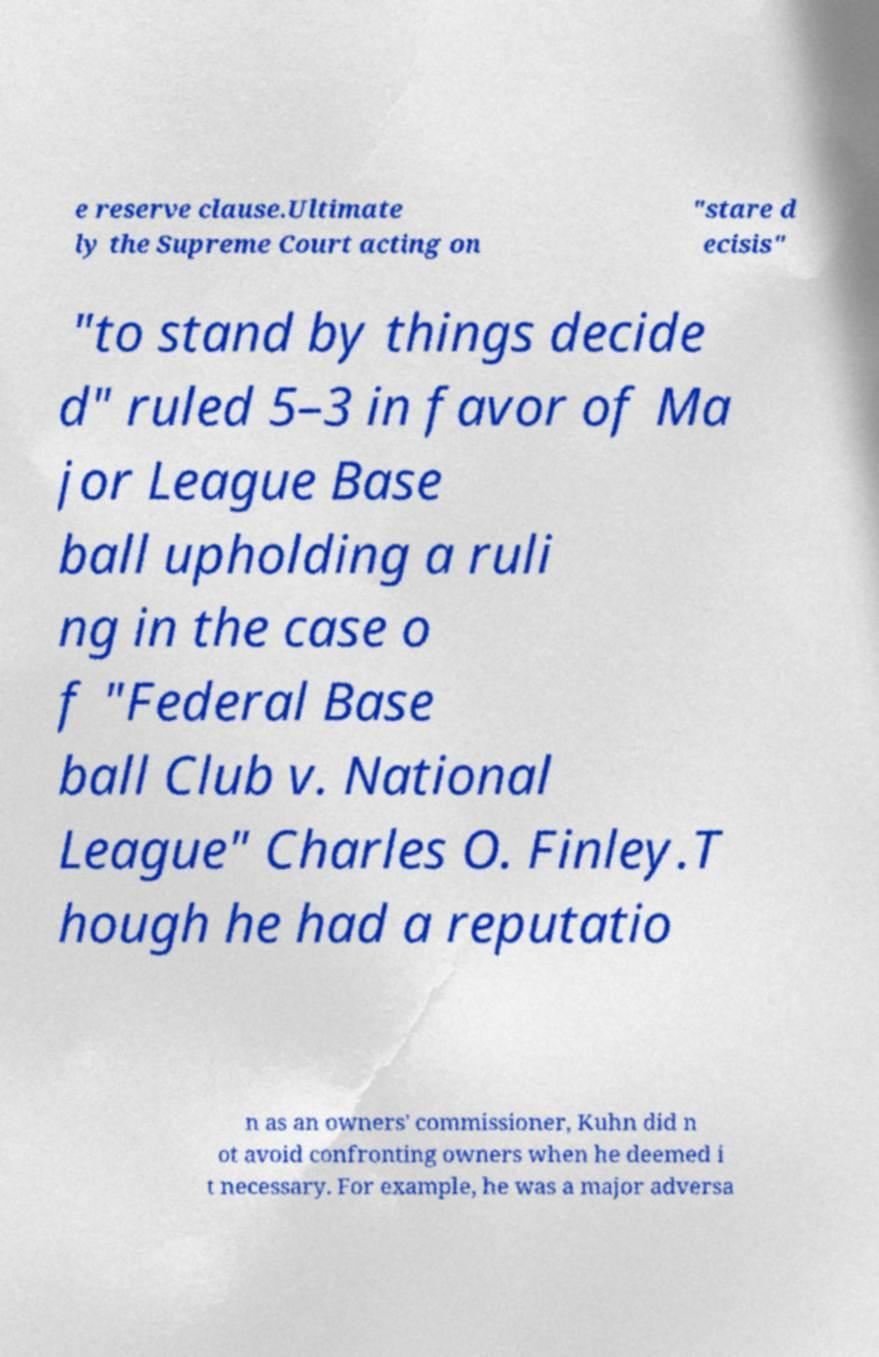Could you assist in decoding the text presented in this image and type it out clearly? e reserve clause.Ultimate ly the Supreme Court acting on "stare d ecisis" "to stand by things decide d" ruled 5–3 in favor of Ma jor League Base ball upholding a ruli ng in the case o f "Federal Base ball Club v. National League" Charles O. Finley.T hough he had a reputatio n as an owners' commissioner, Kuhn did n ot avoid confronting owners when he deemed i t necessary. For example, he was a major adversa 